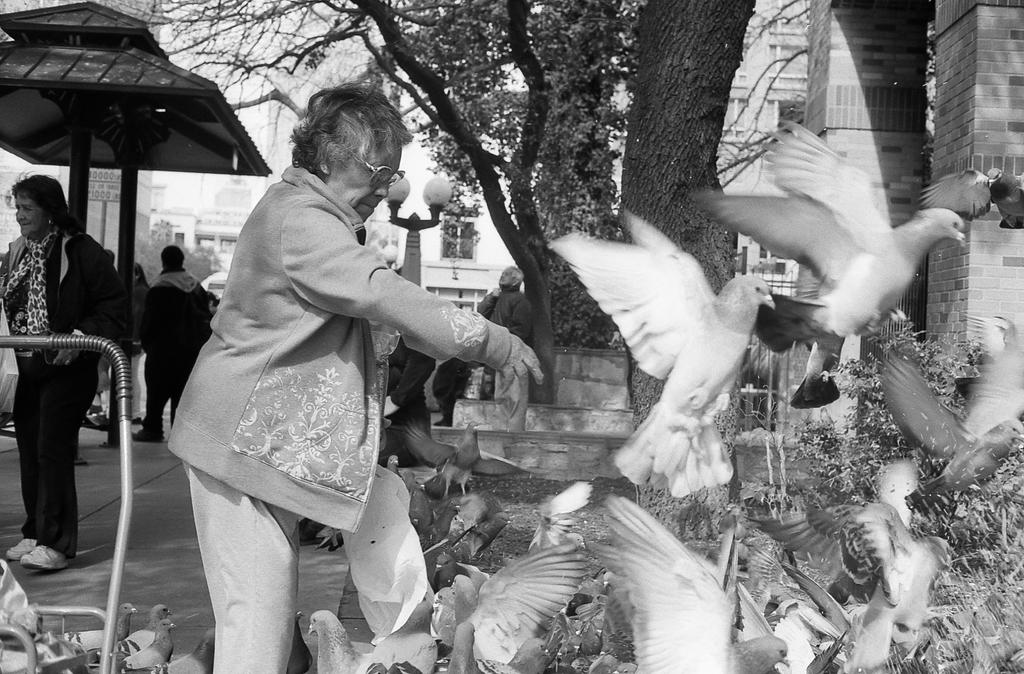What type of animals can be seen in the image? There are birds in the image. Who or what else is present in the image? There are people and plants in the image. What other natural elements can be seen in the image? There are trees in the image. What man-made structures are visible in the image? There is a trolley and buildings in the image. How is the image presented in terms of color? The image is in black and white mode. What weather condition can be seen in the image? The image is in black and white mode, so it is not possible to determine the weather condition from the image. What rule is being enforced by the people in the image? There is no indication of any rule being enforced in the image. Is there a baseball game taking place in the image? There is no indication of a baseball game or any sports activity in the image. 